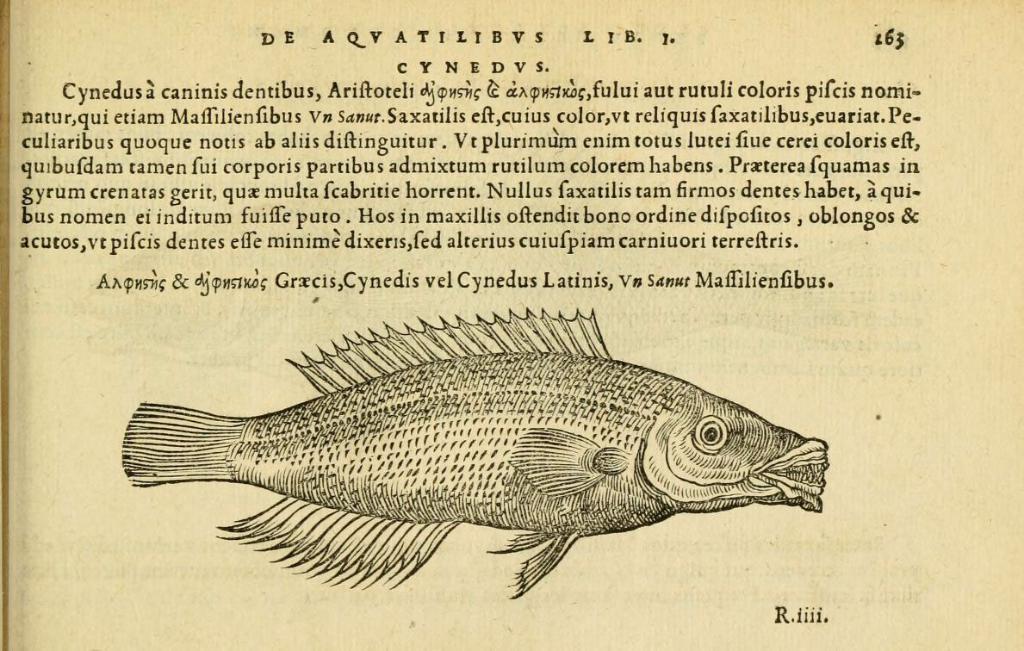In one or two sentences, can you explain what this image depicts? This is the picture of a paper. In this image there is a picture of a fish and there is a text on the paper. 